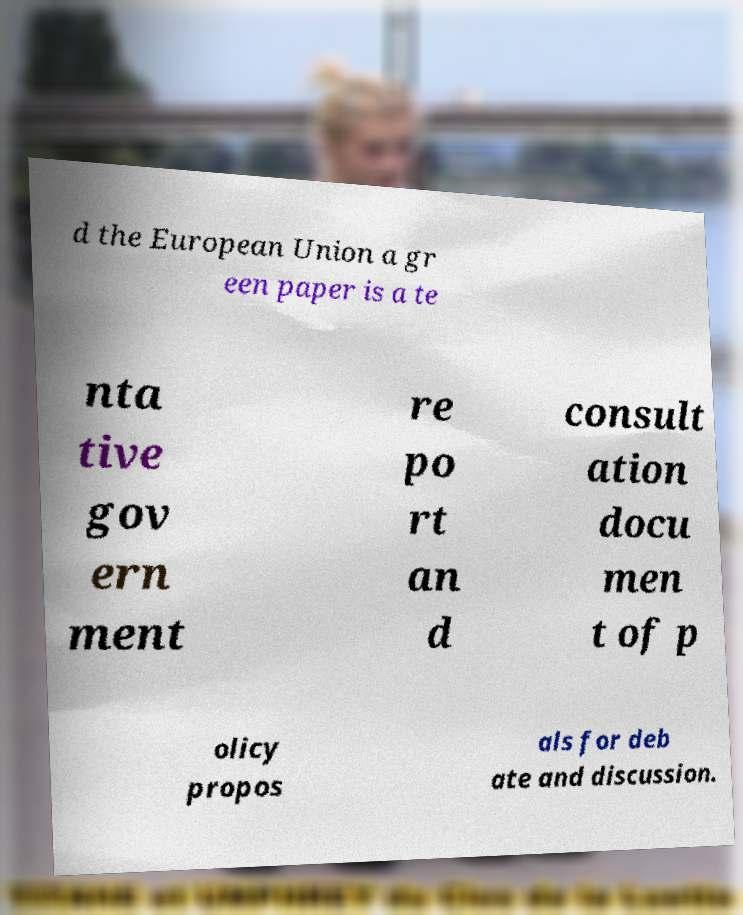What messages or text are displayed in this image? I need them in a readable, typed format. d the European Union a gr een paper is a te nta tive gov ern ment re po rt an d consult ation docu men t of p olicy propos als for deb ate and discussion. 